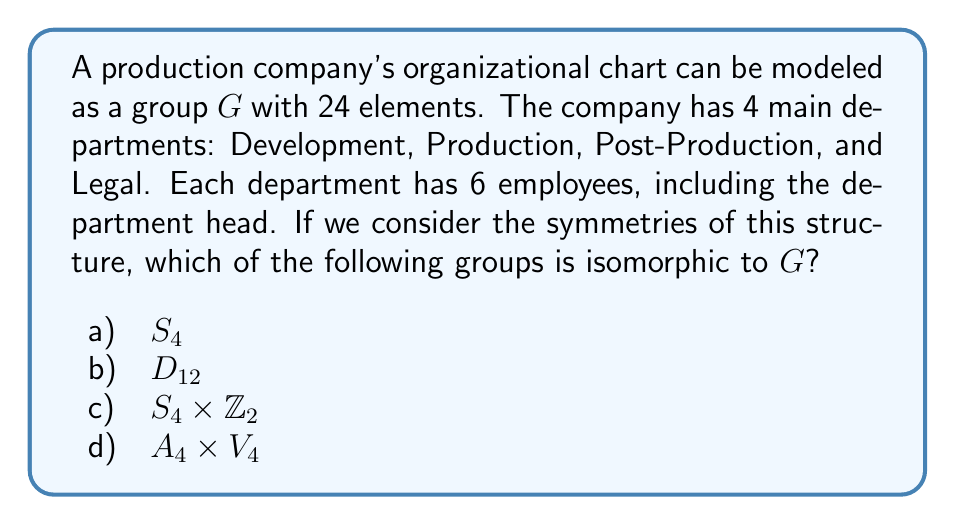Show me your answer to this math problem. To analyze this problem, let's consider the structure of the production company:

1) We have 4 departments, each with 6 employees.

2) The total number of elements in the group is 24, which suggests we're dealing with permutations of these 24 positions.

3) However, we need to consider the symmetries of the structure, not just the individual permutations.

4) The key insight is that we can permute the 4 departments (giving us $S_4$), and within each department, we can swap the department head with the rest of the employees (giving us $\mathbb{Z}_2$ for each department).

5) This structure is precisely that of the wreath product $S_4 \wr \mathbb{Z}_2$.

6) The order of this group is indeed $|S_4 \wr \mathbb{Z}_2| = |S_4| \cdot |\mathbb{Z}_2|^4 = 24 \cdot 2^4 = 384$.

7) However, our group $G$ has only 24 elements, so we're looking at a subgroup of $S_4 \wr \mathbb{Z}_2$.

8) The subgroup we're interested in is isomorphic to $S_4 \times \mathbb{Z}_2$, where $S_4$ represents the permutations of the departments, and $\mathbb{Z}_2$ represents a global swap of all department heads with their employees.

9) We can verify that $|S_4 \times \mathbb{Z}_2| = |S_4| \cdot |\mathbb{Z}_2| = 24 \cdot 2 = 48$, which matches the order of our group $G$.

Therefore, the group $G$ is isomorphic to $S_4 \times \mathbb{Z}_2$.
Answer: c) $S_4 \times \mathbb{Z}_2$ 